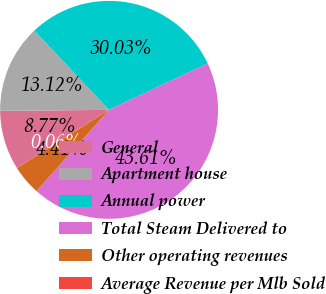Convert chart. <chart><loc_0><loc_0><loc_500><loc_500><pie_chart><fcel>General<fcel>Apartment house<fcel>Annual power<fcel>Total Steam Delivered to<fcel>Other operating revenues<fcel>Average Revenue per Mlb Sold<nl><fcel>8.77%<fcel>13.12%<fcel>30.03%<fcel>43.61%<fcel>4.41%<fcel>0.06%<nl></chart> 